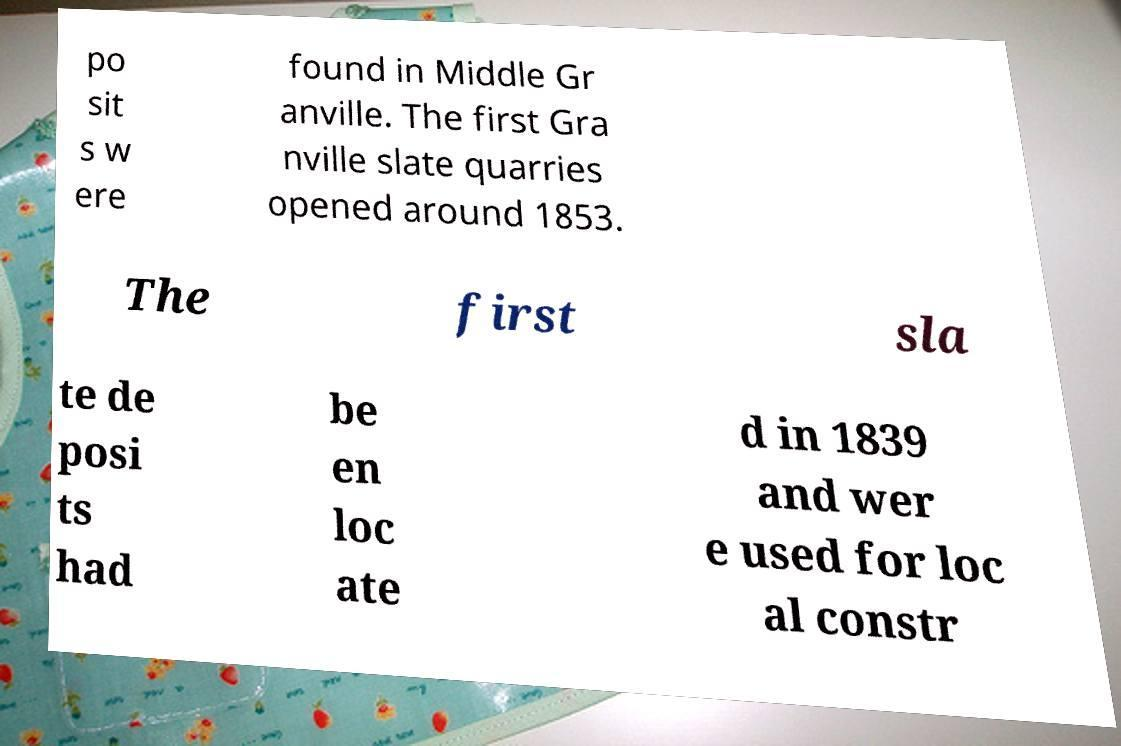Can you accurately transcribe the text from the provided image for me? po sit s w ere found in Middle Gr anville. The first Gra nville slate quarries opened around 1853. The first sla te de posi ts had be en loc ate d in 1839 and wer e used for loc al constr 